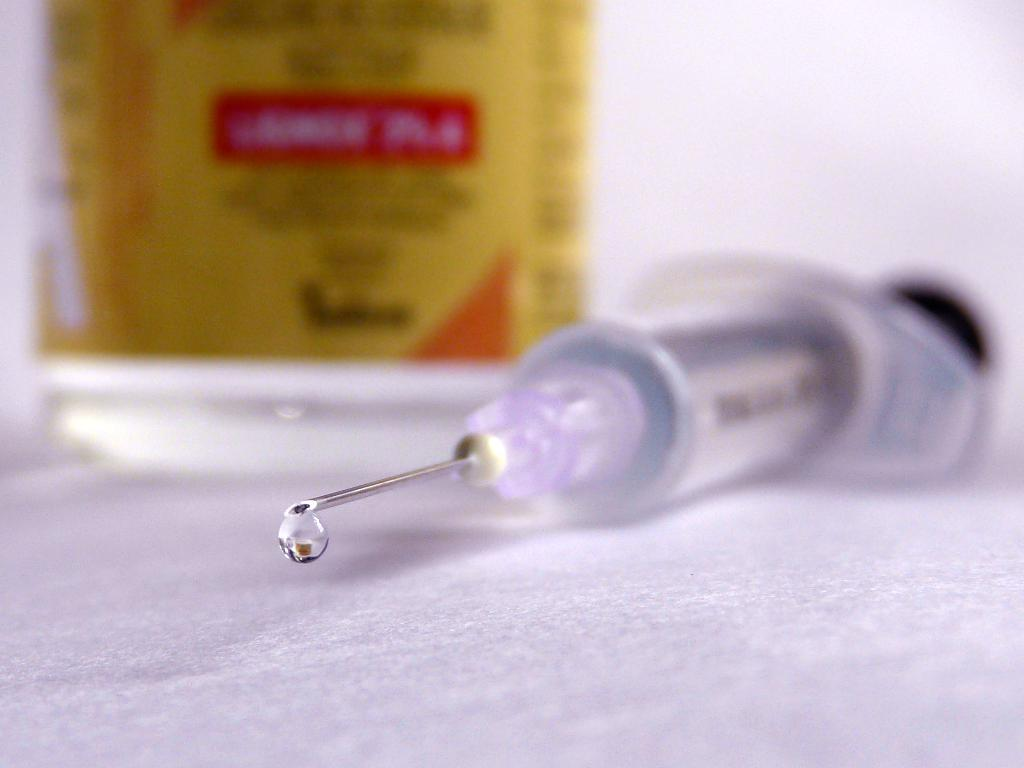What is the main subject of the image? The main subject of the image is an injection. Where is the injection located? The injection is placed on a table. What can be seen in the background of the image? There is an object visible in the background of the image, and there is also a wall. What songs are being sung by the mother in the image? There is no mother or singing present in the image; it features an injection on a table with a background that includes an object and a wall. 